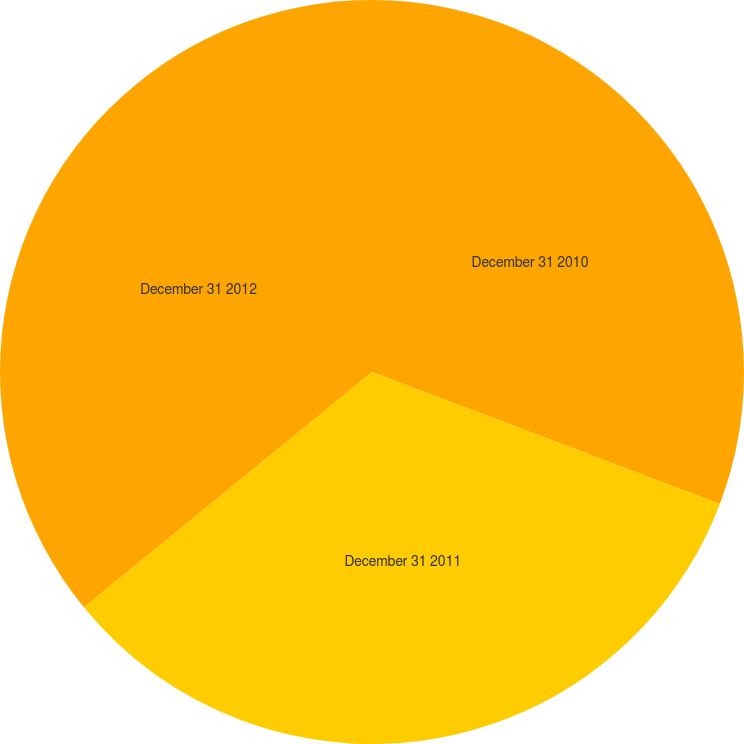<chart> <loc_0><loc_0><loc_500><loc_500><pie_chart><fcel>December 31 2010<fcel>December 31 2011<fcel>December 31 2012<nl><fcel>30.77%<fcel>33.33%<fcel>35.9%<nl></chart> 